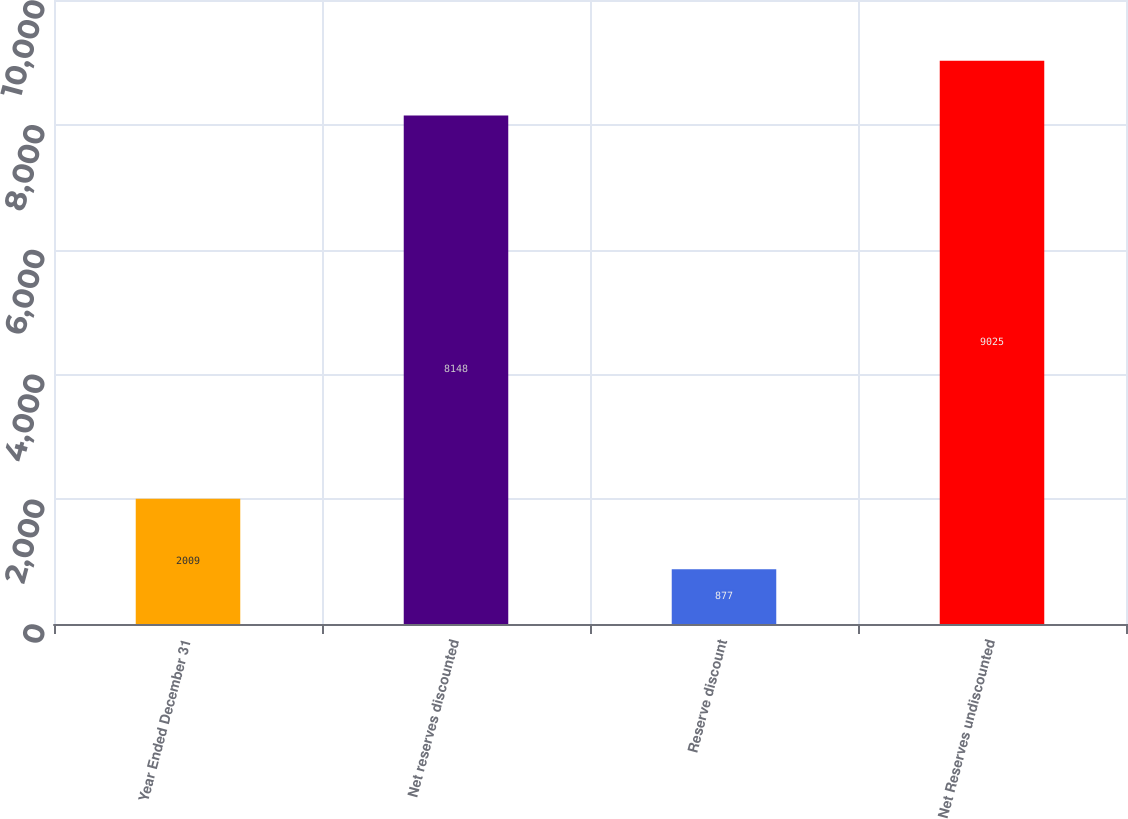Convert chart to OTSL. <chart><loc_0><loc_0><loc_500><loc_500><bar_chart><fcel>Year Ended December 31<fcel>Net reserves discounted<fcel>Reserve discount<fcel>Net Reserves undiscounted<nl><fcel>2009<fcel>8148<fcel>877<fcel>9025<nl></chart> 